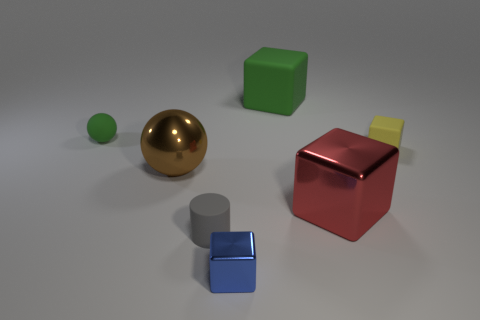Is the color of the large rubber cube the same as the block to the right of the red metallic thing?
Offer a very short reply. No. Is the number of brown shiny things that are behind the yellow cube the same as the number of big red metallic objects behind the large green cube?
Your answer should be very brief. Yes. How many other objects are the same size as the gray matte object?
Your answer should be very brief. 3. The gray rubber object has what size?
Provide a short and direct response. Small. Does the gray cylinder have the same material as the block behind the green rubber ball?
Your answer should be very brief. Yes. Are there any rubber things that have the same shape as the small blue metal object?
Keep it short and to the point. Yes. There is a yellow block that is the same size as the gray cylinder; what material is it?
Give a very brief answer. Rubber. There is a rubber object to the left of the tiny gray rubber cylinder; what size is it?
Provide a succinct answer. Small. There is a block that is behind the green sphere; is its size the same as the rubber cube that is right of the big green rubber object?
Offer a terse response. No. What number of yellow objects have the same material as the gray thing?
Give a very brief answer. 1. 